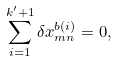Convert formula to latex. <formula><loc_0><loc_0><loc_500><loc_500>\sum _ { i = 1 } ^ { k ^ { \prime } + 1 } \delta x _ { m n } ^ { b ( i ) } = 0 ,</formula> 